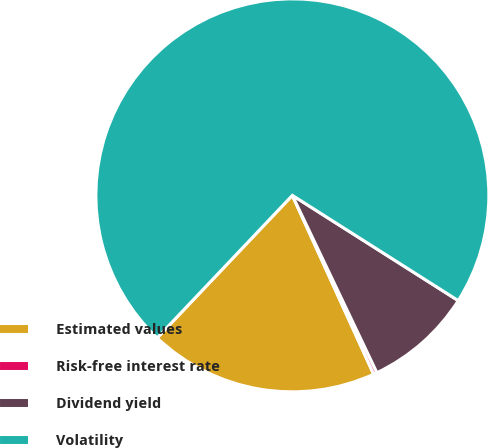Convert chart. <chart><loc_0><loc_0><loc_500><loc_500><pie_chart><fcel>Estimated values<fcel>Risk-free interest rate<fcel>Dividend yield<fcel>Volatility<nl><fcel>18.87%<fcel>0.29%<fcel>8.92%<fcel>71.92%<nl></chart> 